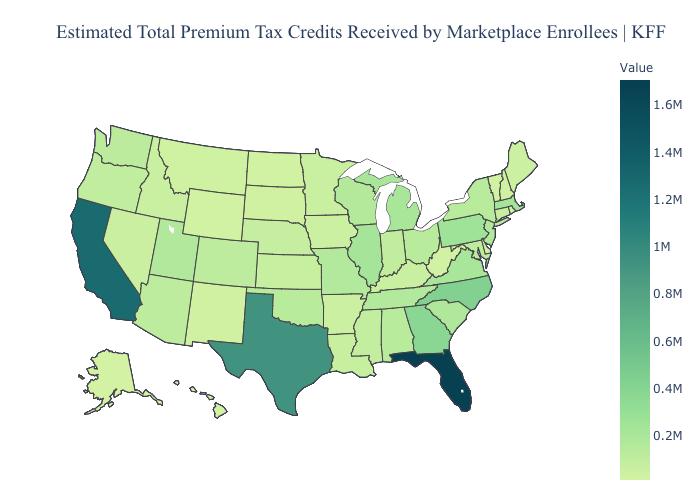Does Vermont have the highest value in the Northeast?
Quick response, please. No. Does Missouri have the highest value in the MidWest?
Keep it brief. No. Among the states that border Tennessee , which have the highest value?
Quick response, please. North Carolina. Does Rhode Island have the lowest value in the USA?
Short answer required. No. Is the legend a continuous bar?
Short answer required. Yes. Does North Carolina have a higher value than California?
Keep it brief. No. Which states have the lowest value in the USA?
Concise answer only. Alaska. 